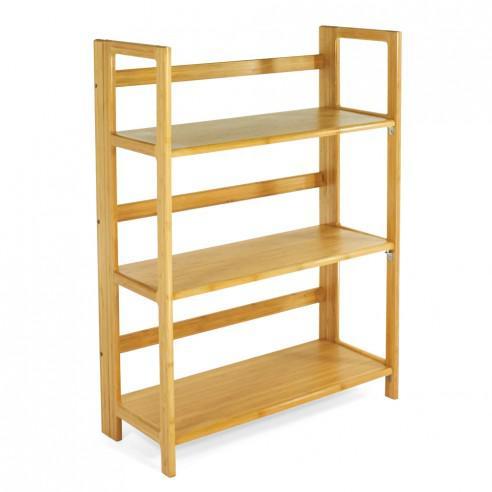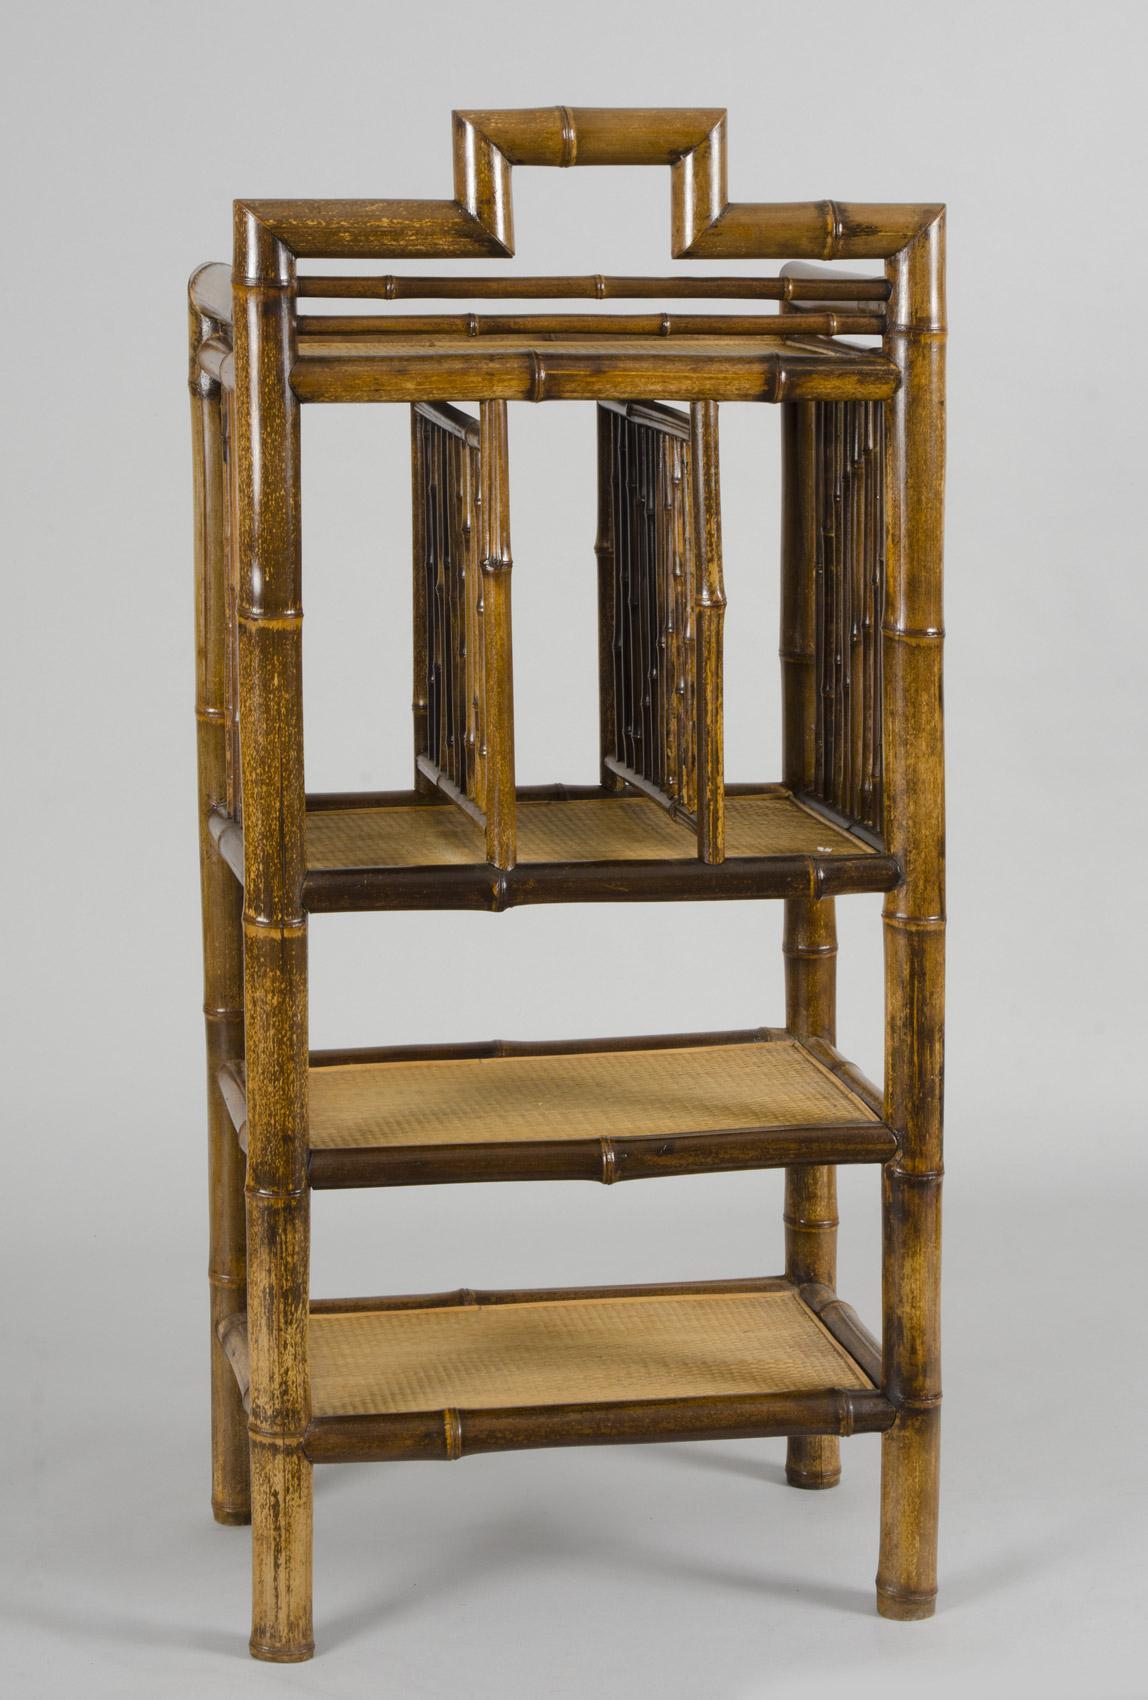The first image is the image on the left, the second image is the image on the right. Evaluate the accuracy of this statement regarding the images: "Left image shows a blond 'traditional' wood shelf unit, and right image shows a rattan shelf unit.". Is it true? Answer yes or no. Yes. 